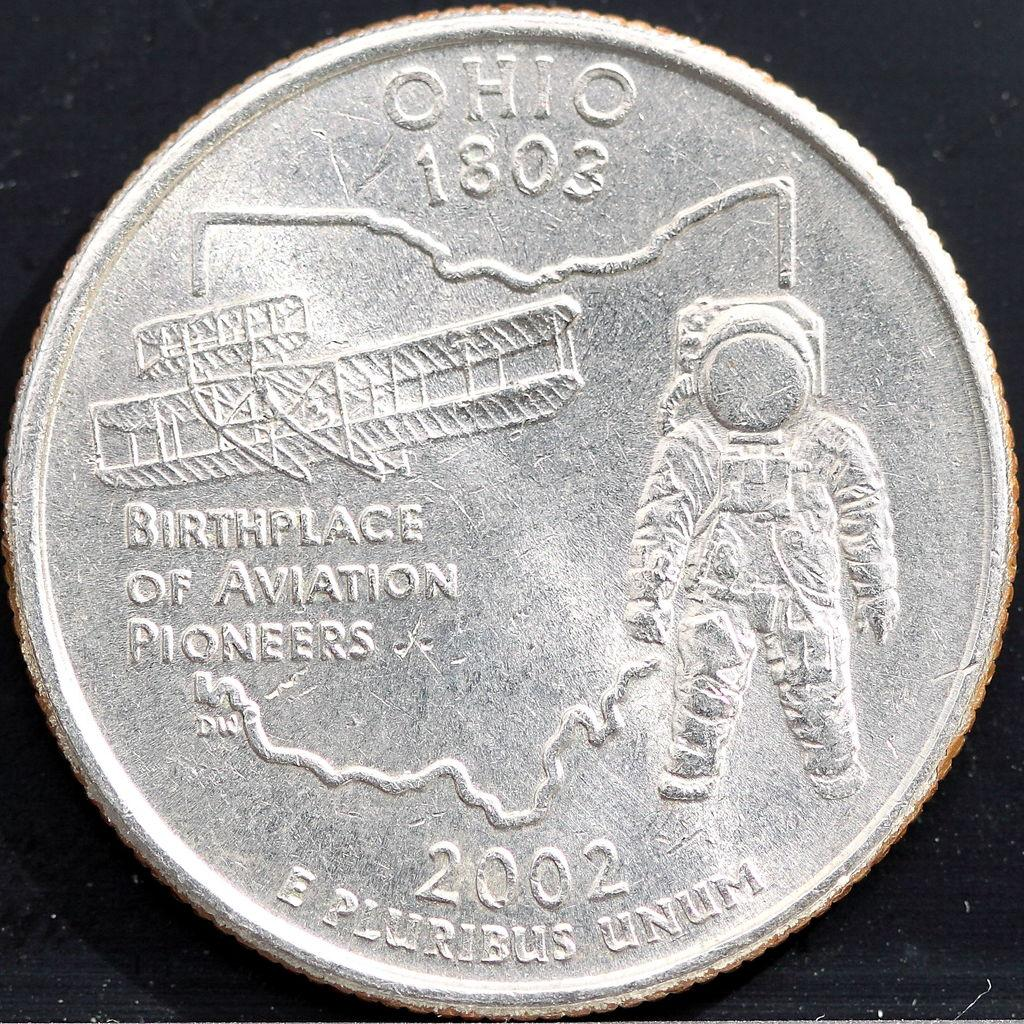What is the color of the coin in the image? The coin in the image is silver in color. Where is the coin located in the image? The coin is in the middle of the photograph. What is depicted on the coin? There is an astronaut printed on the coin. What color is the background of the image? The background of the image is black. Is there a locket containing a picture of a loved one in the image? No, there is no locket present in the image. Does the astronaut on the coin feel any shame about their presence on the coin? The astronaut on the coin is an inanimate object and cannot feel emotions like shame. 